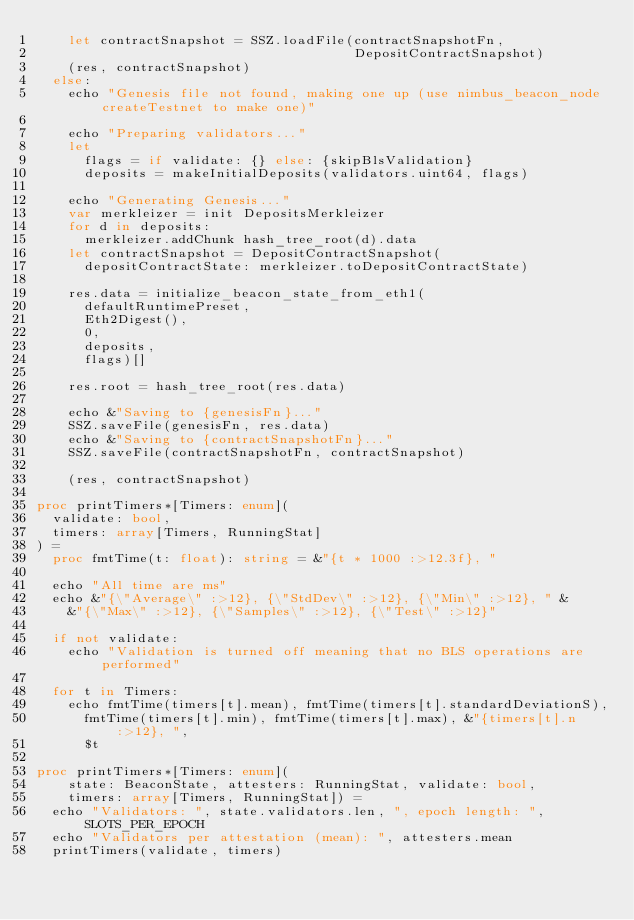Convert code to text. <code><loc_0><loc_0><loc_500><loc_500><_Nim_>    let contractSnapshot = SSZ.loadFile(contractSnapshotFn,
                                        DepositContractSnapshot)
    (res, contractSnapshot)
  else:
    echo "Genesis file not found, making one up (use nimbus_beacon_node createTestnet to make one)"

    echo "Preparing validators..."
    let
      flags = if validate: {} else: {skipBlsValidation}
      deposits = makeInitialDeposits(validators.uint64, flags)

    echo "Generating Genesis..."
    var merkleizer = init DepositsMerkleizer
    for d in deposits:
      merkleizer.addChunk hash_tree_root(d).data
    let contractSnapshot = DepositContractSnapshot(
      depositContractState: merkleizer.toDepositContractState)

    res.data = initialize_beacon_state_from_eth1(
      defaultRuntimePreset,
      Eth2Digest(),
      0,
      deposits,
      flags)[]

    res.root = hash_tree_root(res.data)

    echo &"Saving to {genesisFn}..."
    SSZ.saveFile(genesisFn, res.data)
    echo &"Saving to {contractSnapshotFn}..."
    SSZ.saveFile(contractSnapshotFn, contractSnapshot)

    (res, contractSnapshot)

proc printTimers*[Timers: enum](
  validate: bool,
  timers: array[Timers, RunningStat]
) =
  proc fmtTime(t: float): string = &"{t * 1000 :>12.3f}, "

  echo "All time are ms"
  echo &"{\"Average\" :>12}, {\"StdDev\" :>12}, {\"Min\" :>12}, " &
    &"{\"Max\" :>12}, {\"Samples\" :>12}, {\"Test\" :>12}"

  if not validate:
    echo "Validation is turned off meaning that no BLS operations are performed"

  for t in Timers:
    echo fmtTime(timers[t].mean), fmtTime(timers[t].standardDeviationS),
      fmtTime(timers[t].min), fmtTime(timers[t].max), &"{timers[t].n :>12}, ",
      $t

proc printTimers*[Timers: enum](
    state: BeaconState, attesters: RunningStat, validate: bool,
    timers: array[Timers, RunningStat]) =
  echo "Validators: ", state.validators.len, ", epoch length: ", SLOTS_PER_EPOCH
  echo "Validators per attestation (mean): ", attesters.mean
  printTimers(validate, timers)
</code> 